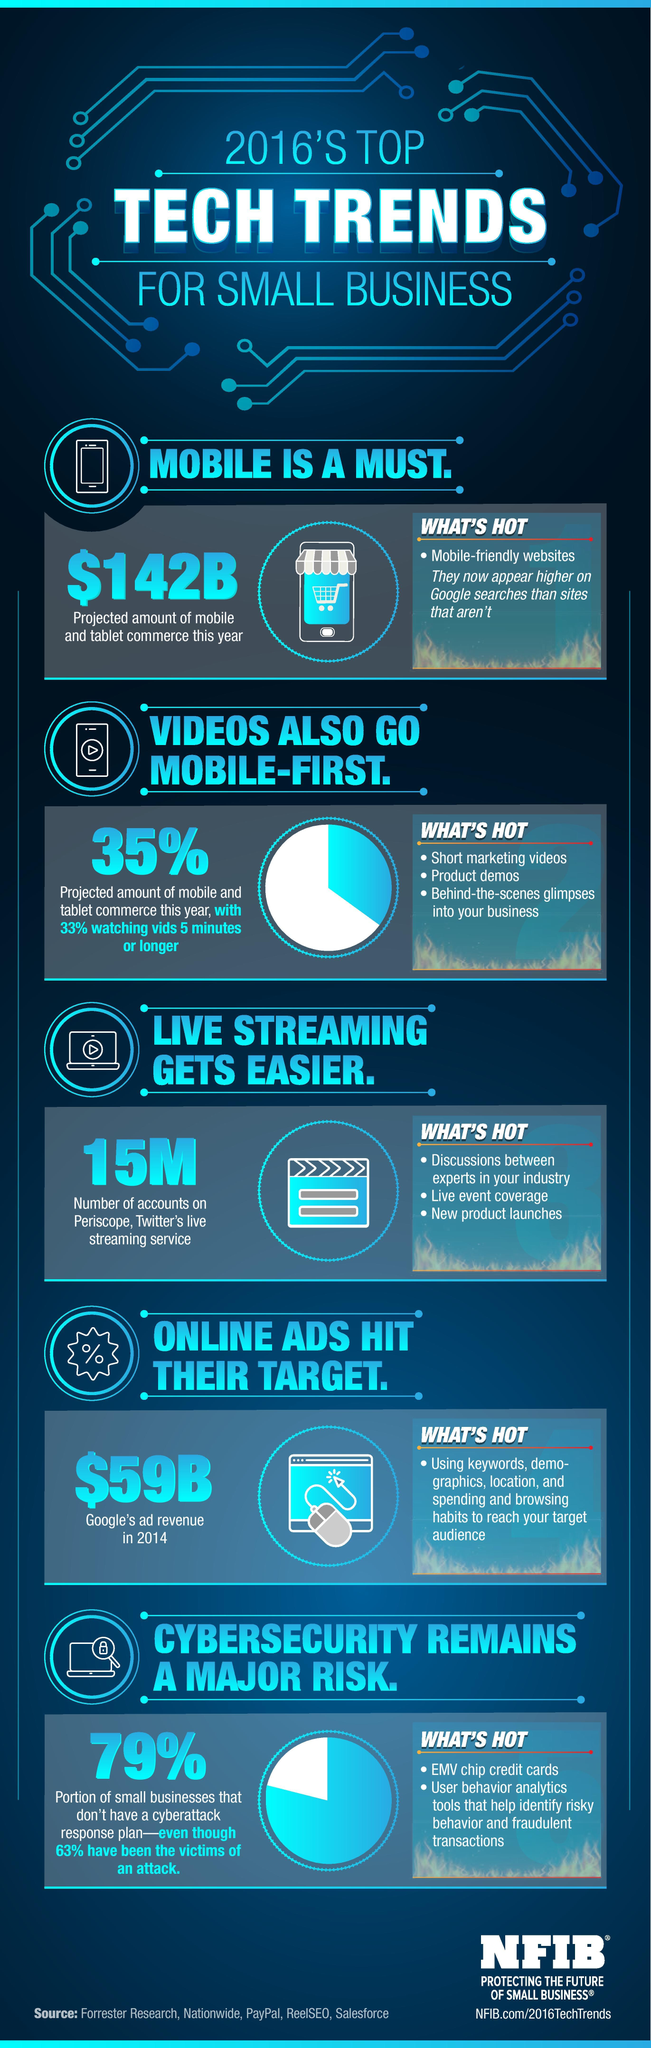Outline some significant characteristics in this image. A significant percentage, or 79%, of small businesses do not have a cyberattack response plan in place. According to the data, a significant percentage of users do not watch videos that are 5 minutes or longer. Specifically, 67% of the users do not watch such videos. Mobile-friendly websites tend to rank higher on Google search results than websites that are not optimized for mobile devices. We reach our target audience by utilizing keywords, demographics, location, spending and browsing habits, and other relevant data to effectively and efficiently connect with our intended audience. 